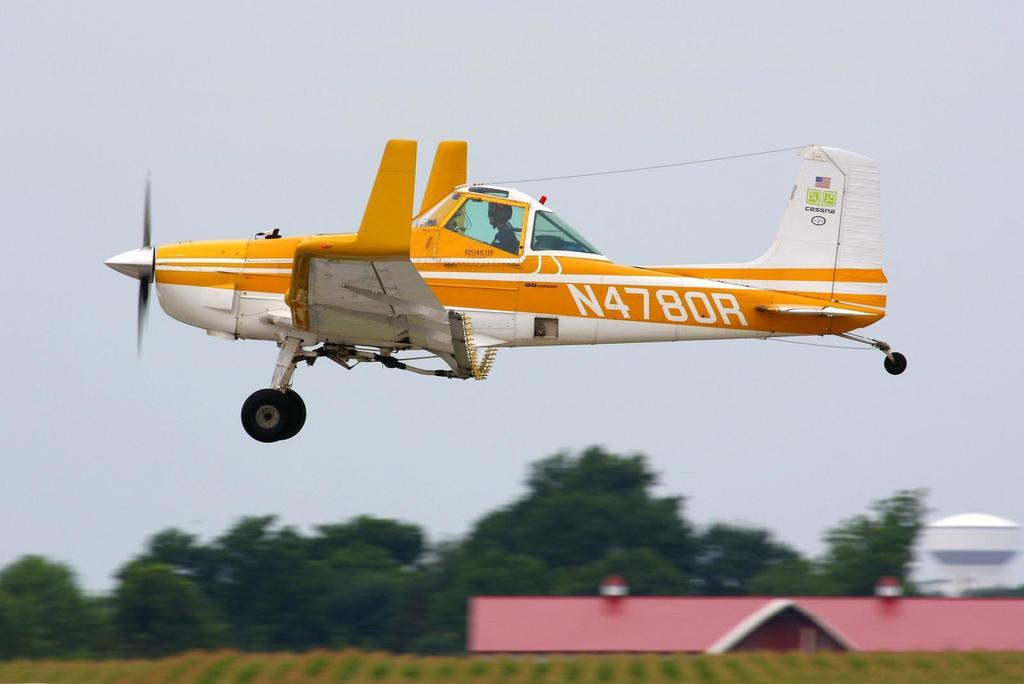<image>
Relay a brief, clear account of the picture shown. A yellow plane with the numbers N4780R written upon its side. 